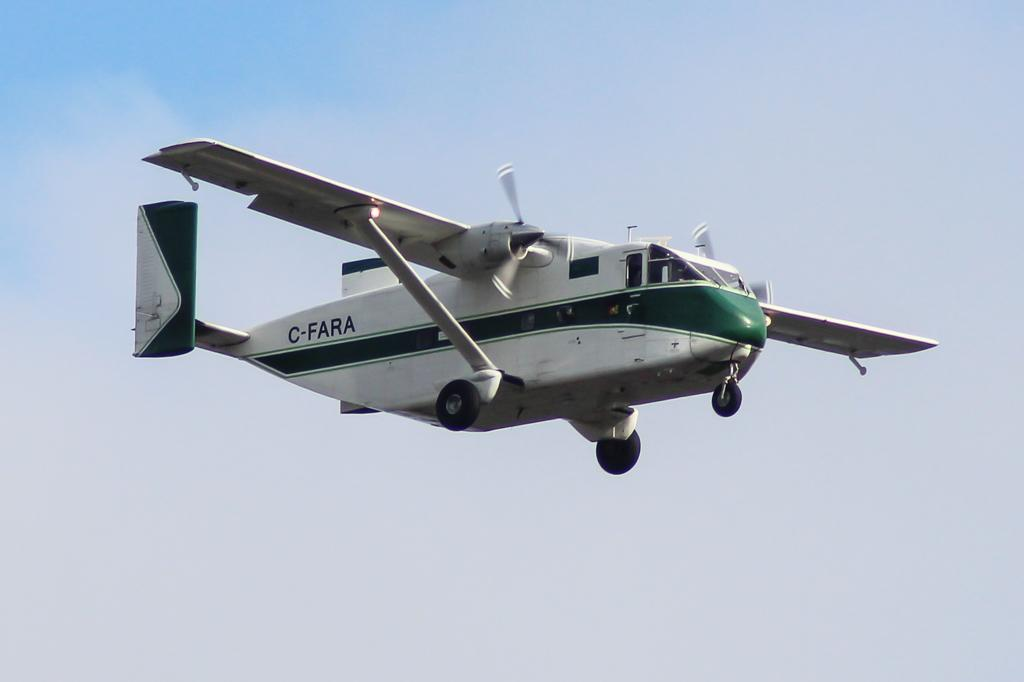<image>
Relay a brief, clear account of the picture shown. A white airplane with a green stripe is flying with C-FARA near the tail. 